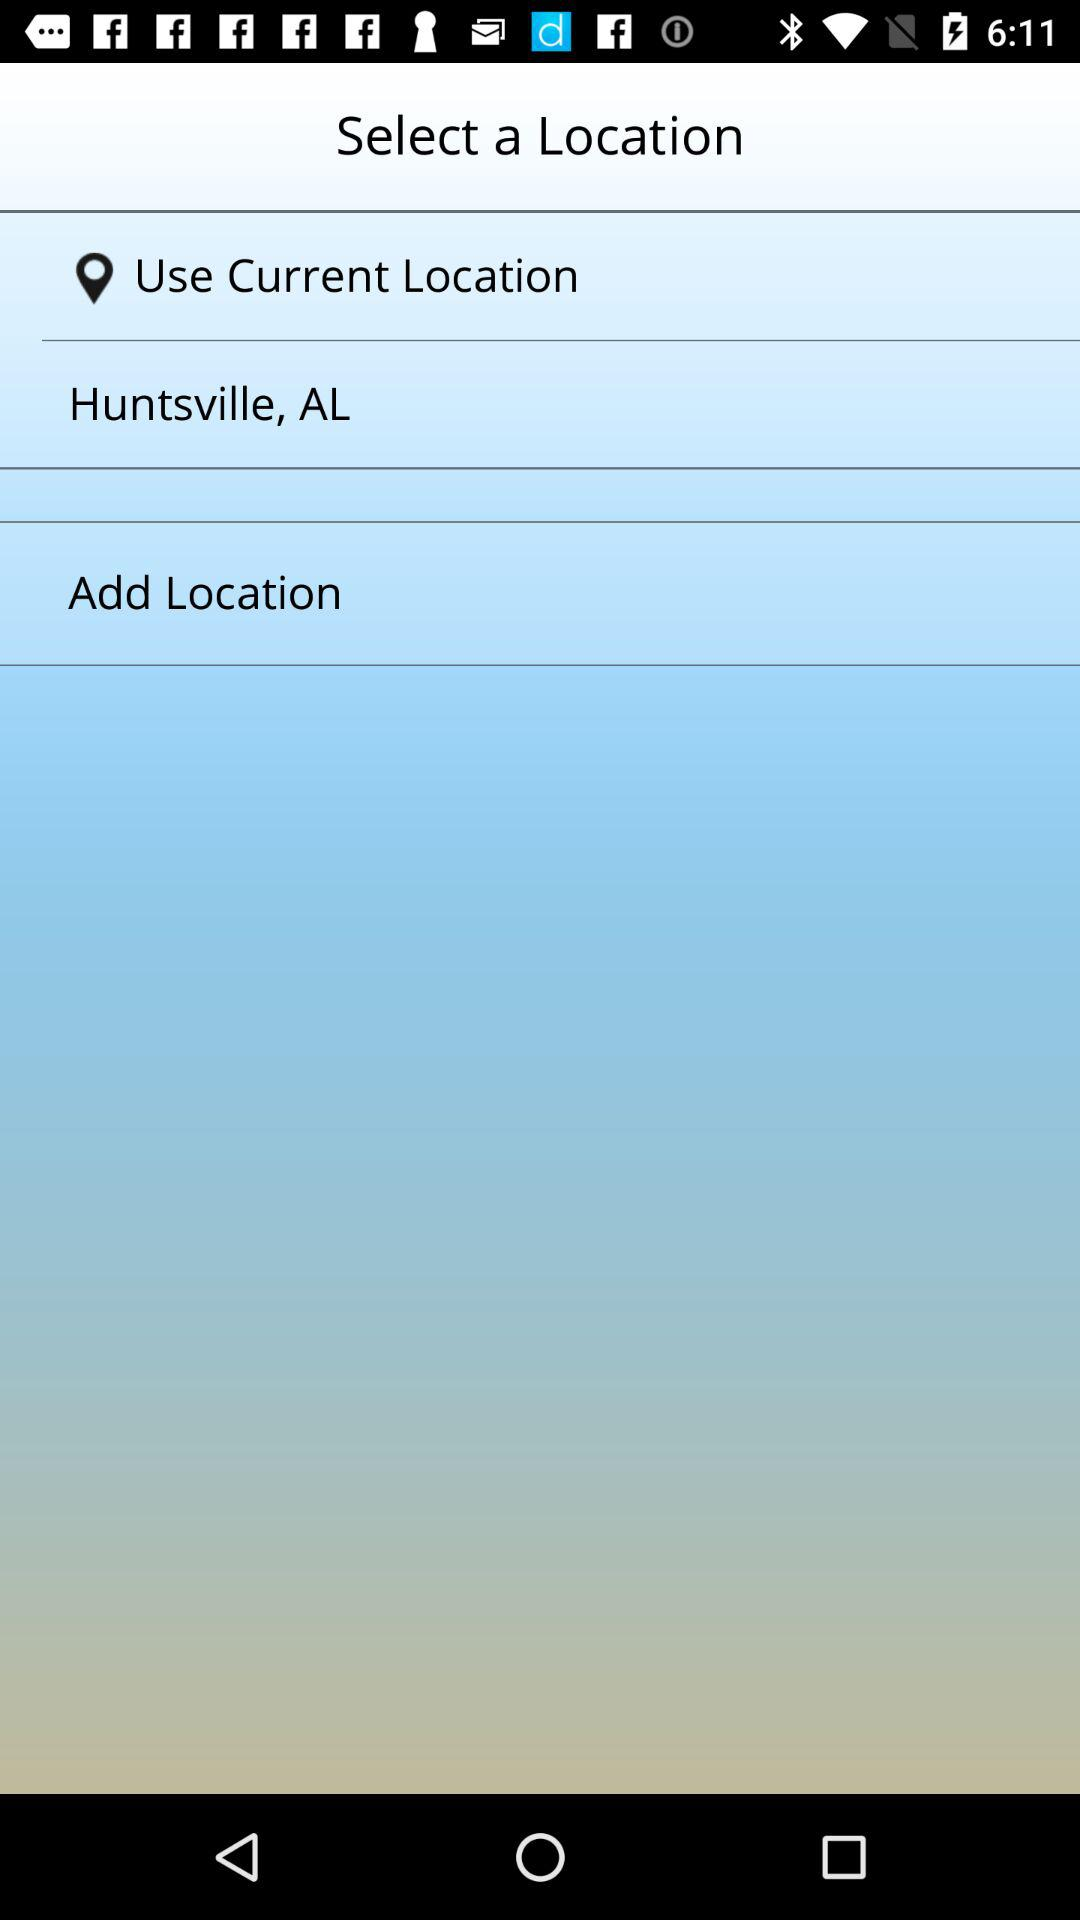What is the current location? The current location is "Huntsville, AL". 